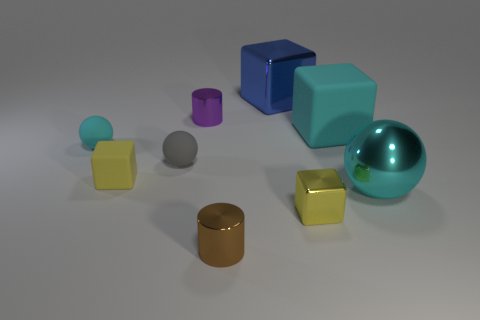Subtract all yellow cubes. How many were subtracted if there are1yellow cubes left? 1 Add 1 big green matte objects. How many objects exist? 10 Subtract all blocks. How many objects are left? 5 Subtract 0 purple balls. How many objects are left? 9 Subtract all tiny brown shiny objects. Subtract all tiny rubber things. How many objects are left? 5 Add 2 cyan matte spheres. How many cyan matte spheres are left? 3 Add 6 large brown rubber balls. How many large brown rubber balls exist? 6 